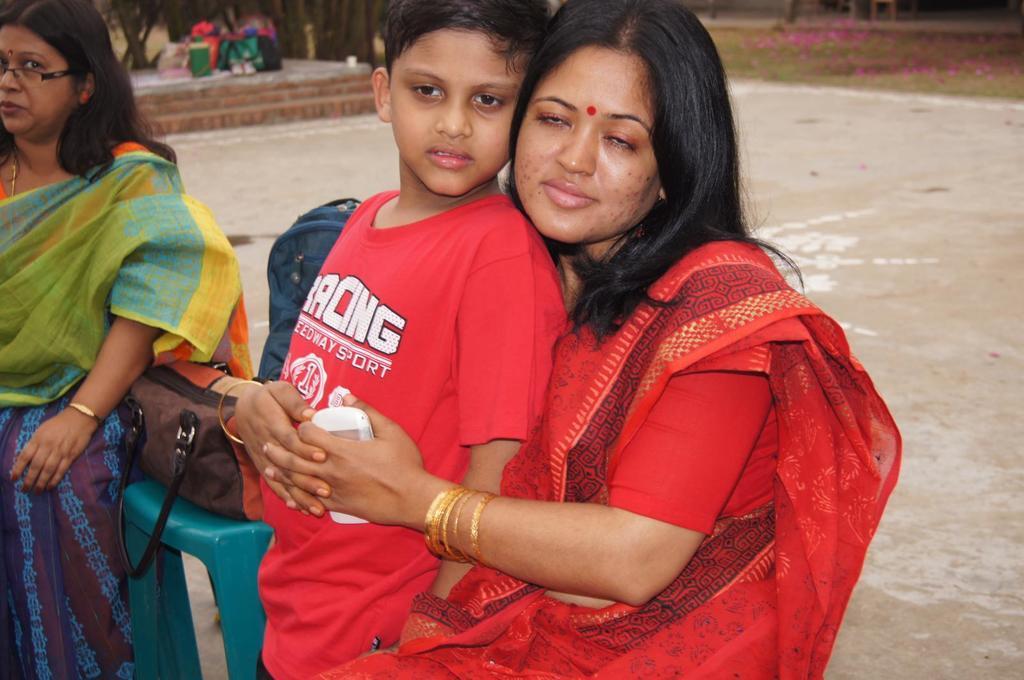How would you summarize this image in a sentence or two? In this picture, there is a woman holding a boy. Both of them are wearing red clothes. Woman is wearing a saree and a kid is wearing a red t shirt. Towards the left, there is another woman wearing a saree. Beside her, there is a chair. On the chair, there are bags. In the background there are trees and grass. 